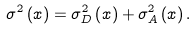<formula> <loc_0><loc_0><loc_500><loc_500>\sigma ^ { 2 } \left ( x \right ) = \sigma _ { D } ^ { 2 } \left ( x \right ) + \sigma _ { A } ^ { 2 } \left ( x \right ) .</formula> 